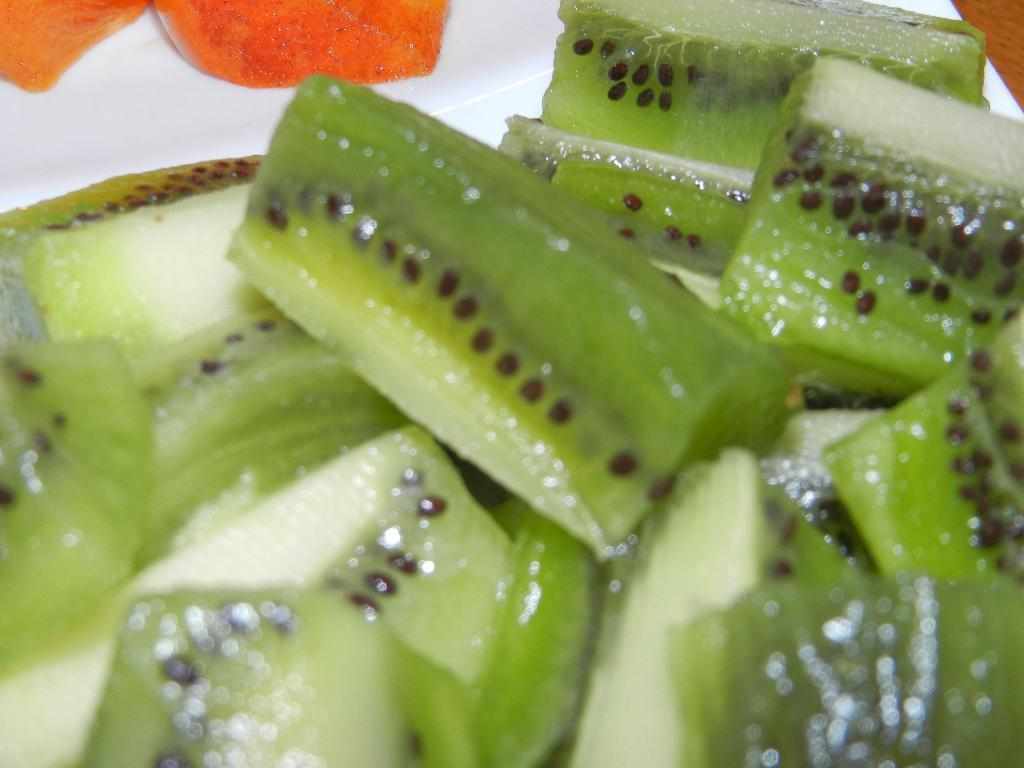What types of items can be seen in the image? There are food items in the image. What is the color of the surface on which the food items are placed? The food items are on a white surface. How does the credit card smell in the image? There is no credit card present in the image, so it cannot be smelled or have a smell. 